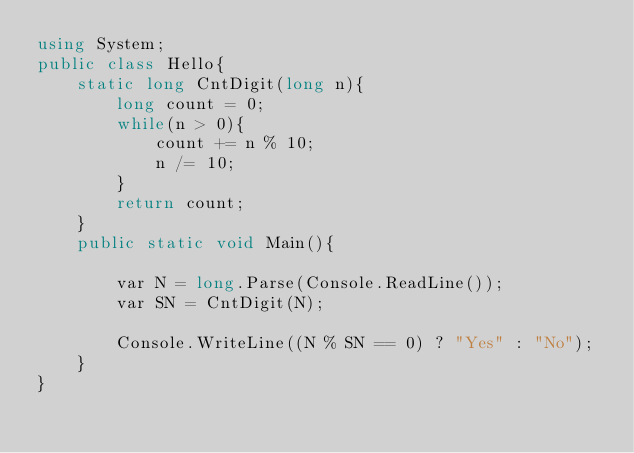<code> <loc_0><loc_0><loc_500><loc_500><_C#_>using System;
public class Hello{
    static long CntDigit(long n){
        long count = 0;
        while(n > 0){
            count += n % 10;
            n /= 10;
        }
        return count;
    }
    public static void Main(){
        
        var N = long.Parse(Console.ReadLine());
        var SN = CntDigit(N);
        
        Console.WriteLine((N % SN == 0) ? "Yes" : "No");
    }
}
</code> 